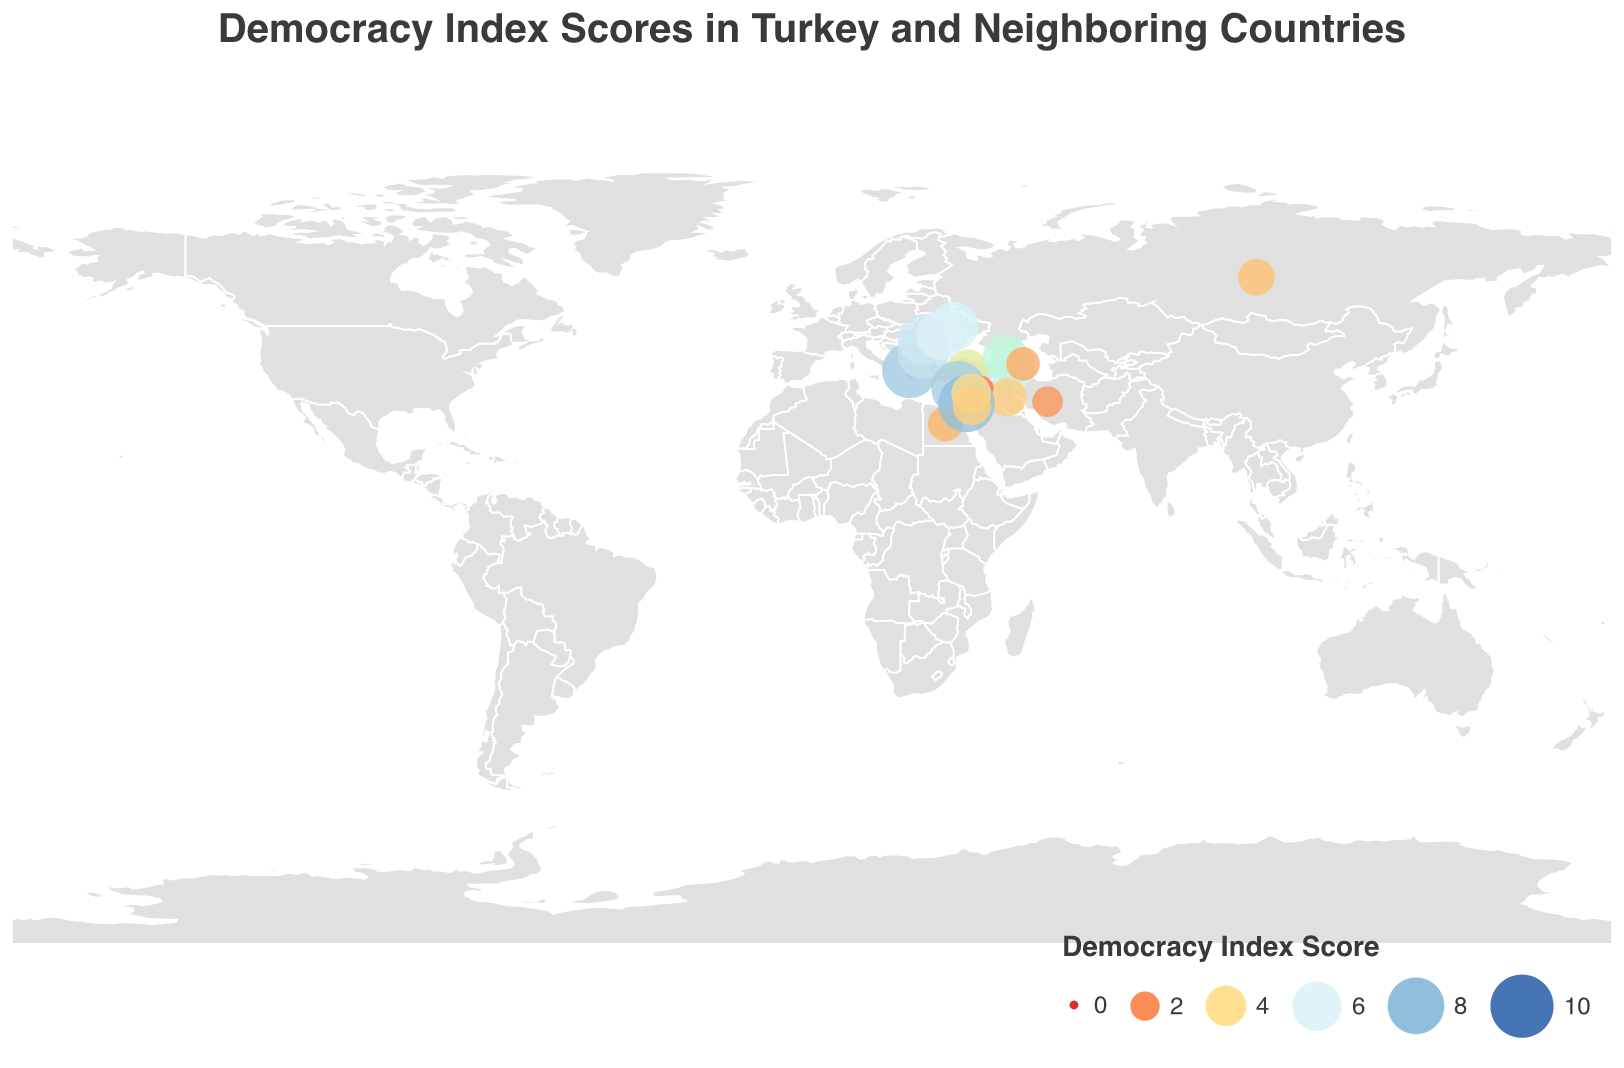What's the Democracy Index Score for Turkey? The figure includes a tooltip showing the Democracy Index Score for each country. Hovering over Turkey in the figure displays a score of 4.35.
Answer: 4.35 Which neighboring country of Turkey has the highest Democracy Index Score? By examining the colored circles on the map, it is evident that Israel has the highest score of 7.97 among Turkey's neighbors.
Answer: Israel How does Turkey's Democracy Index Score compare to Greece's? By comparing the colored circles for Turkey and Greece, we see that Greece has a higher score of 7.56 while Turkey's score is 4.35.
Answer: Greece has a higher score What's the average Democracy Index Score of Turkey's immediate neighbors? Turkey's immediate neighbors and their scores are: Greece (7.56), Bulgaria (6.64), Armenia (5.49), Georgia (5.12), Iran (2.20), Iraq (3.51), Syria (1.43). Calculate the average: (7.56 + 6.64 + 5.49 + 5.12 + 2.20 + 3.51 + 1.43) / 7 = 4.28.
Answer: 4.28 Which region surrounding Turkey has the most countries with lower Democracy Index Scores than Turkey? By examining the Democracy Index Scores: Middle East (Turkey 4.35 vs. Iran 2.20, Iraq 3.51, Syria 1.43, Jordan 3.56, Lebanon 3.84, Egypt 2.93) has the most countries with lower scores.
Answer: Middle East What is the color representing the highest Democracy Index Score among the displayed countries? The color scale ranges from red to blue, with the highest scores in a darker blue. Israel has the highest score (7.97) shown in dark blue.
Answer: Dark blue How many countries in Eastern Europe have a higher Democracy Index Score than Turkey? For Eastern Europe, countries are Bulgaria (6.64), Ukraine (5.81), Romania (6.43), Moldova (6.10), and Russia (3.24). Four countries have higher scores than Turkey.
Answer: Four What is the median Democracy Index Score of the countries listed in the plot? List all scores: 1.43, 2.20, 2.68, 2.93, 3.24, 3.51, 3.56, 3.84, 4.35, 5.12, 5.49, 5.81, 6.10, 6.43, 6.64, 7.43, 7.56, 7.97. The median of 18 values is (4.35+5.12)/2 = 4.735.
Answer: 4.735 Which country has the lowest Democracy Index Score and what is it? By locating the smallest circle and lightest color, Syria has the lowest score of 1.43.
Answer: Syria What are the Democracy Index Scores of the Caucasus countries? The Caucasus countries are Armenia, Georgia, and Azerbaijan with scores of 5.49, 5.12, and 2.68 respectively.
Answer: Armenia 5.49, Georgia 5.12, Azerbaijan 2.68 